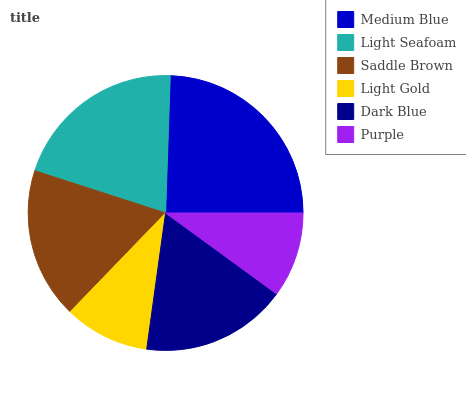Is Purple the minimum?
Answer yes or no. Yes. Is Medium Blue the maximum?
Answer yes or no. Yes. Is Light Seafoam the minimum?
Answer yes or no. No. Is Light Seafoam the maximum?
Answer yes or no. No. Is Medium Blue greater than Light Seafoam?
Answer yes or no. Yes. Is Light Seafoam less than Medium Blue?
Answer yes or no. Yes. Is Light Seafoam greater than Medium Blue?
Answer yes or no. No. Is Medium Blue less than Light Seafoam?
Answer yes or no. No. Is Saddle Brown the high median?
Answer yes or no. Yes. Is Dark Blue the low median?
Answer yes or no. Yes. Is Dark Blue the high median?
Answer yes or no. No. Is Light Seafoam the low median?
Answer yes or no. No. 